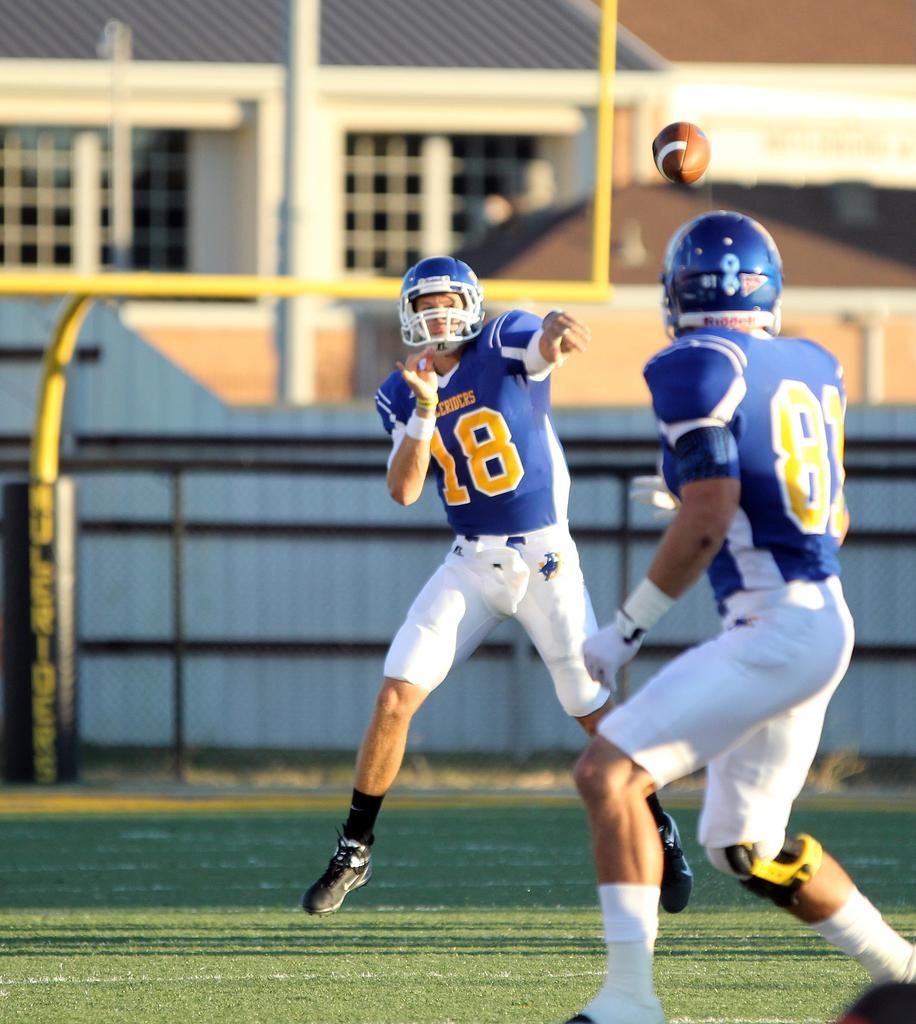Can you describe this image briefly? In the image we can see there are people, playing on the ground, they are wearing clothes, socks, shoes and helmet. There is a ball, grass, building and window of the building, this is a pole. 